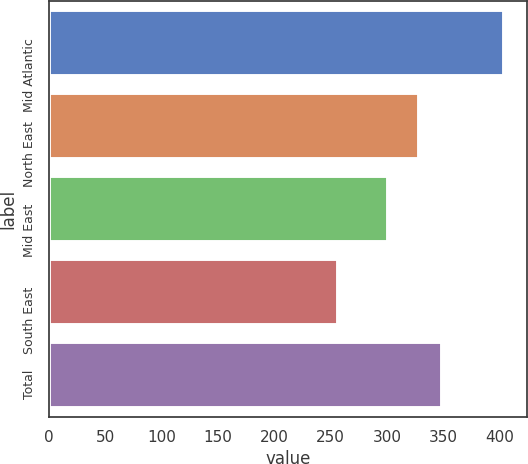<chart> <loc_0><loc_0><loc_500><loc_500><bar_chart><fcel>Mid Atlantic<fcel>North East<fcel>Mid East<fcel>South East<fcel>Total<nl><fcel>404<fcel>328.4<fcel>300.4<fcel>256.7<fcel>349.1<nl></chart> 